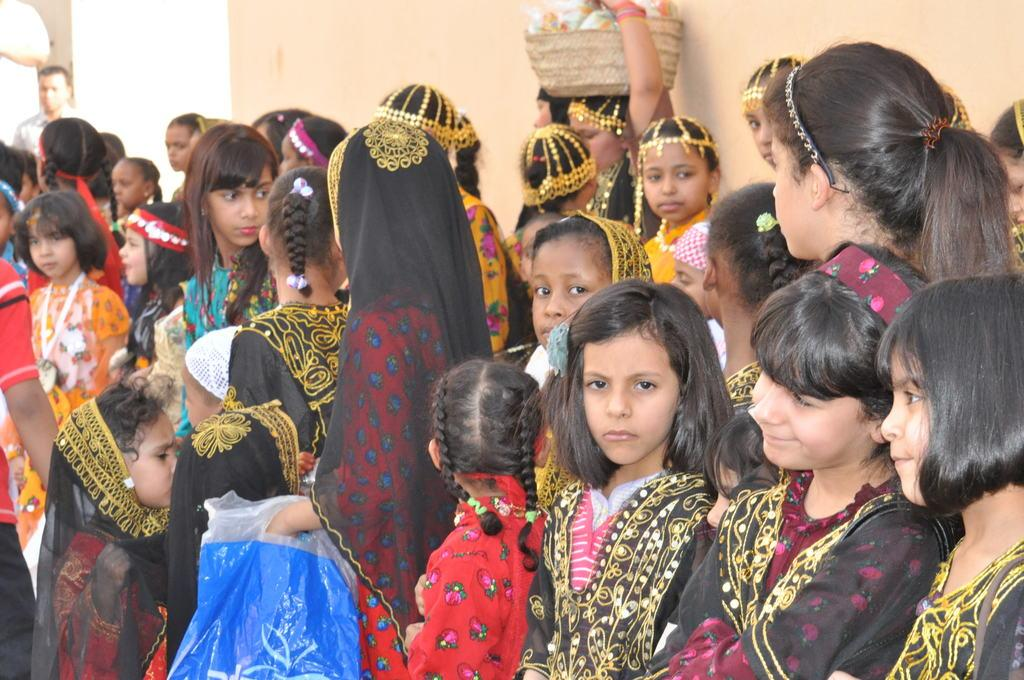What is happening in the image? There are people standing in the image. What can be seen in the background of the image? There is a cream-colored wall in the background of the image. What type of whistle can be heard in the image? There is no whistle present in the image, and therefore no sound can be heard. 